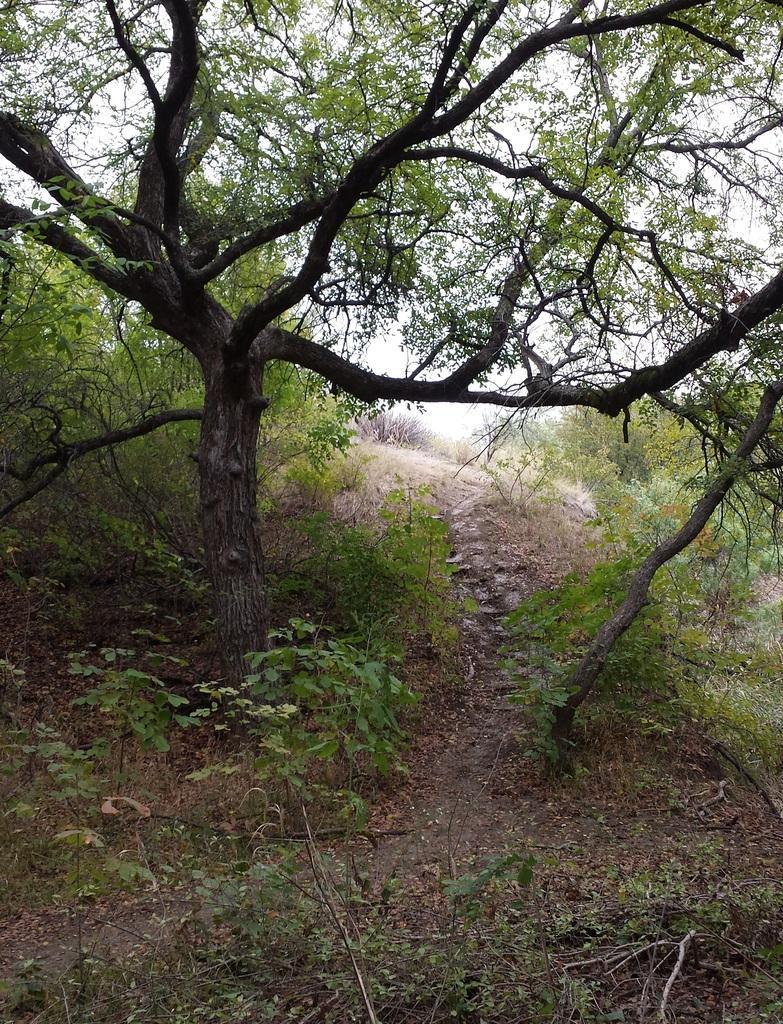Please provide a concise description of this image. In the background we can see the sky. In this picture we can see the trees and the plants. It looks like a forest area. 